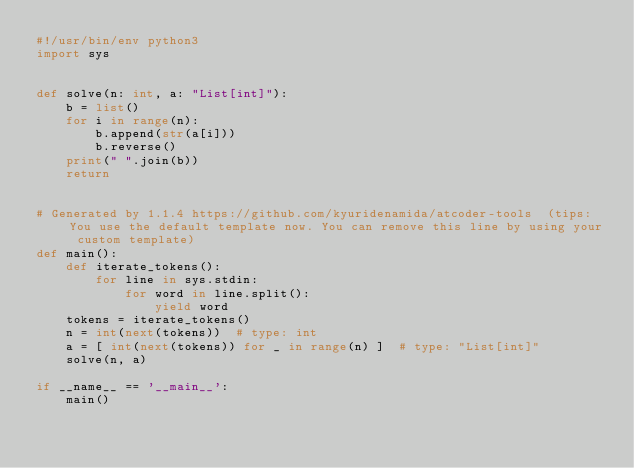Convert code to text. <code><loc_0><loc_0><loc_500><loc_500><_Python_>#!/usr/bin/env python3
import sys


def solve(n: int, a: "List[int]"):
    b = list()
    for i in range(n):
        b.append(str(a[i]))
        b.reverse()
    print(" ".join(b))
    return


# Generated by 1.1.4 https://github.com/kyuridenamida/atcoder-tools  (tips: You use the default template now. You can remove this line by using your custom template)
def main():
    def iterate_tokens():
        for line in sys.stdin:
            for word in line.split():
                yield word
    tokens = iterate_tokens()
    n = int(next(tokens))  # type: int
    a = [ int(next(tokens)) for _ in range(n) ]  # type: "List[int]"
    solve(n, a)

if __name__ == '__main__':
    main()
</code> 